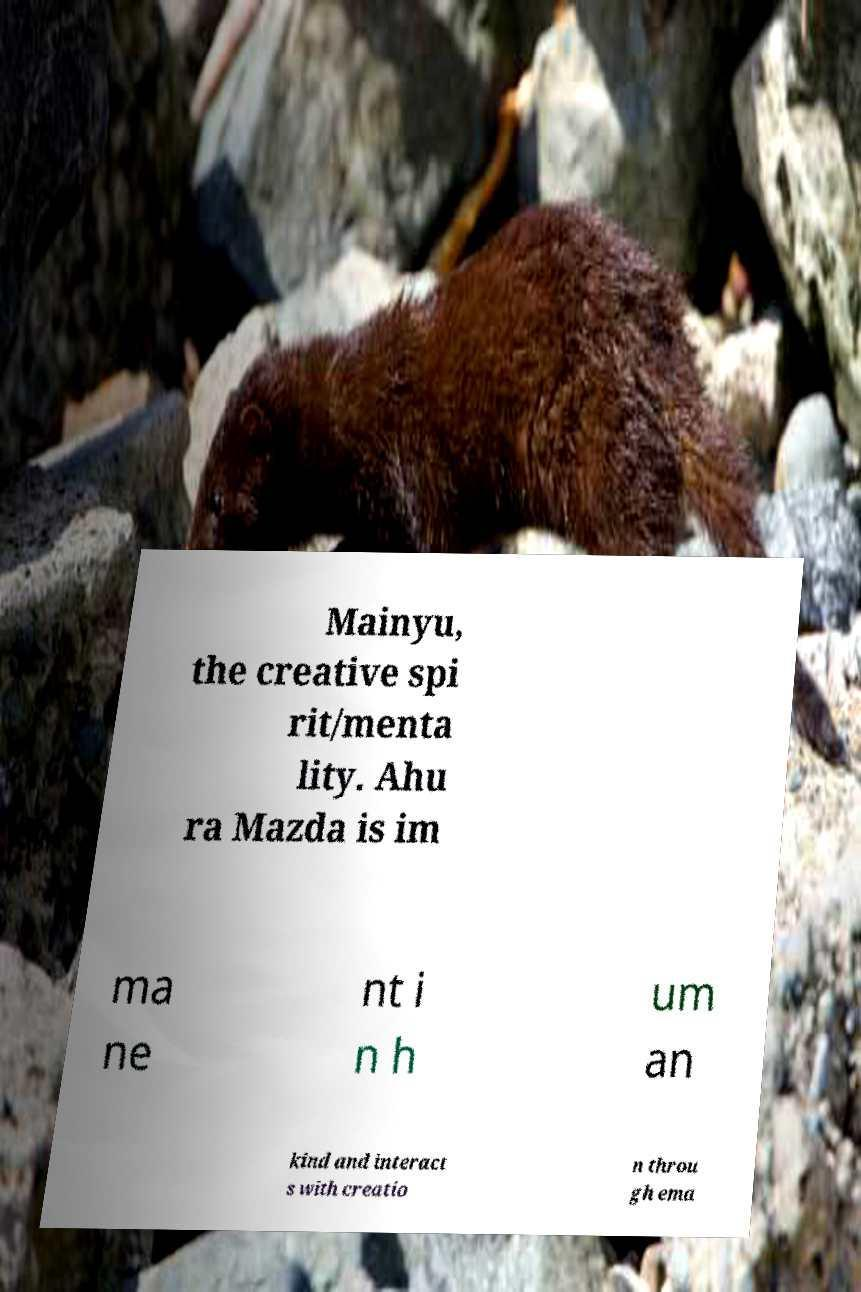Please read and relay the text visible in this image. What does it say? Mainyu, the creative spi rit/menta lity. Ahu ra Mazda is im ma ne nt i n h um an kind and interact s with creatio n throu gh ema 